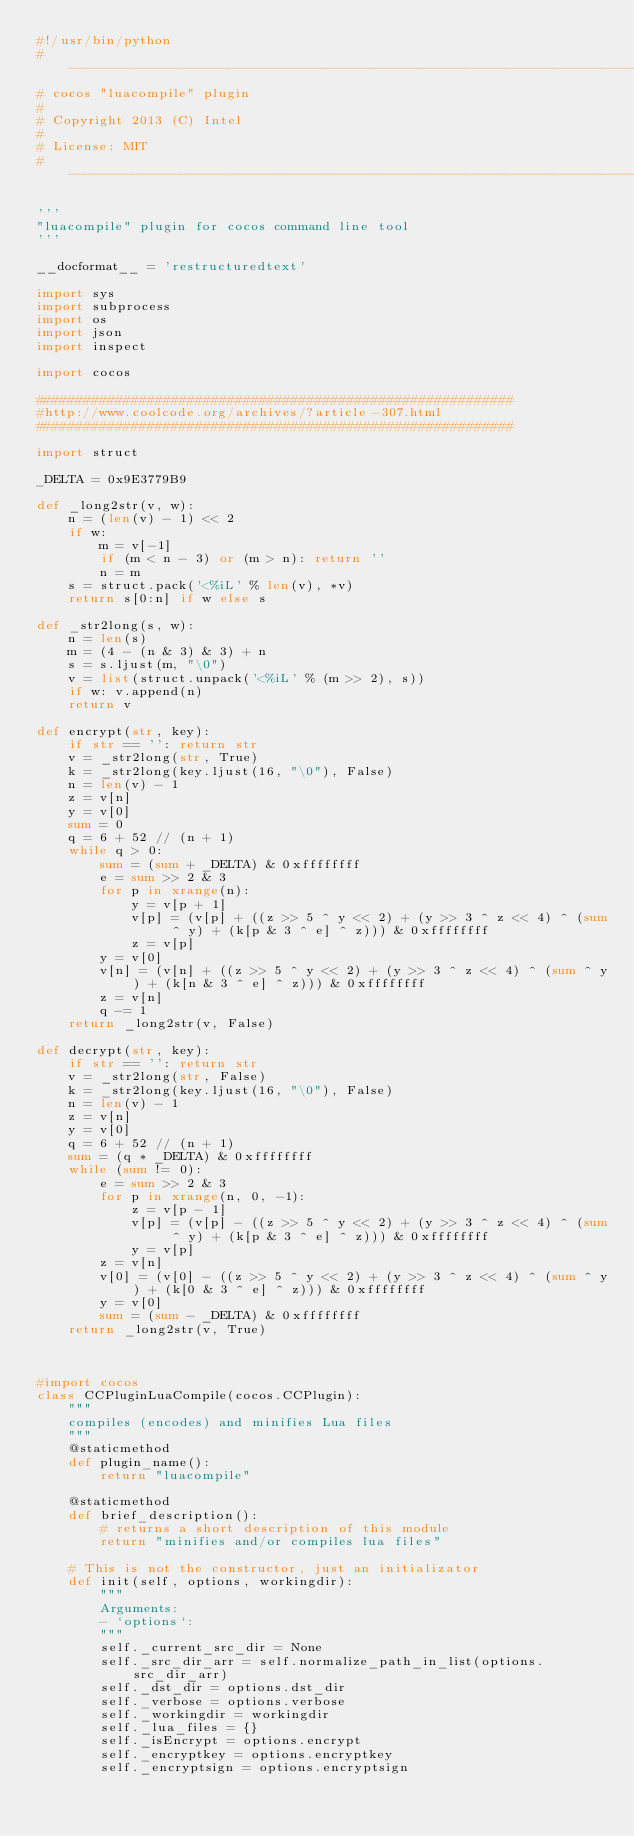<code> <loc_0><loc_0><loc_500><loc_500><_Python_>#!/usr/bin/python
# ----------------------------------------------------------------------------
# cocos "luacompile" plugin
#
# Copyright 2013 (C) Intel
#
# License: MIT
# ----------------------------------------------------------------------------

'''
"luacompile" plugin for cocos command line tool
'''

__docformat__ = 'restructuredtext'

import sys
import subprocess
import os
import json
import inspect

import cocos

############################################################ 
#http://www.coolcode.org/archives/?article-307.html
############################################################ 

import struct 

_DELTA = 0x9E3779B9  

def _long2str(v, w):  
    n = (len(v) - 1) << 2  
    if w:  
        m = v[-1]  
        if (m < n - 3) or (m > n): return ''  
        n = m  
    s = struct.pack('<%iL' % len(v), *v)  
    return s[0:n] if w else s  
  
def _str2long(s, w):  
    n = len(s)  
    m = (4 - (n & 3) & 3) + n  
    s = s.ljust(m, "\0")  
    v = list(struct.unpack('<%iL' % (m >> 2), s))  
    if w: v.append(n)  
    return v  
  
def encrypt(str, key):  
    if str == '': return str  
    v = _str2long(str, True)  
    k = _str2long(key.ljust(16, "\0"), False)  
    n = len(v) - 1  
    z = v[n]  
    y = v[0]  
    sum = 0  
    q = 6 + 52 // (n + 1)  
    while q > 0:  
        sum = (sum + _DELTA) & 0xffffffff  
        e = sum >> 2 & 3  
        for p in xrange(n):  
            y = v[p + 1]  
            v[p] = (v[p] + ((z >> 5 ^ y << 2) + (y >> 3 ^ z << 4) ^ (sum ^ y) + (k[p & 3 ^ e] ^ z))) & 0xffffffff  
            z = v[p]  
        y = v[0]  
        v[n] = (v[n] + ((z >> 5 ^ y << 2) + (y >> 3 ^ z << 4) ^ (sum ^ y) + (k[n & 3 ^ e] ^ z))) & 0xffffffff  
        z = v[n]  
        q -= 1  
    return _long2str(v, False)  
  
def decrypt(str, key):  
    if str == '': return str  
    v = _str2long(str, False)  
    k = _str2long(key.ljust(16, "\0"), False)  
    n = len(v) - 1  
    z = v[n]  
    y = v[0]  
    q = 6 + 52 // (n + 1)  
    sum = (q * _DELTA) & 0xffffffff  
    while (sum != 0):  
        e = sum >> 2 & 3  
        for p in xrange(n, 0, -1):  
            z = v[p - 1]  
            v[p] = (v[p] - ((z >> 5 ^ y << 2) + (y >> 3 ^ z << 4) ^ (sum ^ y) + (k[p & 3 ^ e] ^ z))) & 0xffffffff  
            y = v[p]  
        z = v[n]  
        v[0] = (v[0] - ((z >> 5 ^ y << 2) + (y >> 3 ^ z << 4) ^ (sum ^ y) + (k[0 & 3 ^ e] ^ z))) & 0xffffffff  
        y = v[0]  
        sum = (sum - _DELTA) & 0xffffffff  
    return _long2str(v, True)  



#import cocos
class CCPluginLuaCompile(cocos.CCPlugin):
    """
    compiles (encodes) and minifies Lua files
    """
    @staticmethod
    def plugin_name():
        return "luacompile"

    @staticmethod
    def brief_description():
        # returns a short description of this module
        return "minifies and/or compiles lua files"

    # This is not the constructor, just an initializator
    def init(self, options, workingdir):
        """
        Arguments:
        - `options`:
        """
        self._current_src_dir = None
        self._src_dir_arr = self.normalize_path_in_list(options.src_dir_arr)
        self._dst_dir = options.dst_dir
        self._verbose = options.verbose
        self._workingdir = workingdir
        self._lua_files = {}
        self._isEncrypt = options.encrypt
        self._encryptkey = options.encryptkey
        self._encryptsign = options.encryptsign</code> 